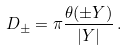Convert formula to latex. <formula><loc_0><loc_0><loc_500><loc_500>D _ { \pm } = \pi \frac { \theta ( \pm Y ) } { | Y | } \, .</formula> 